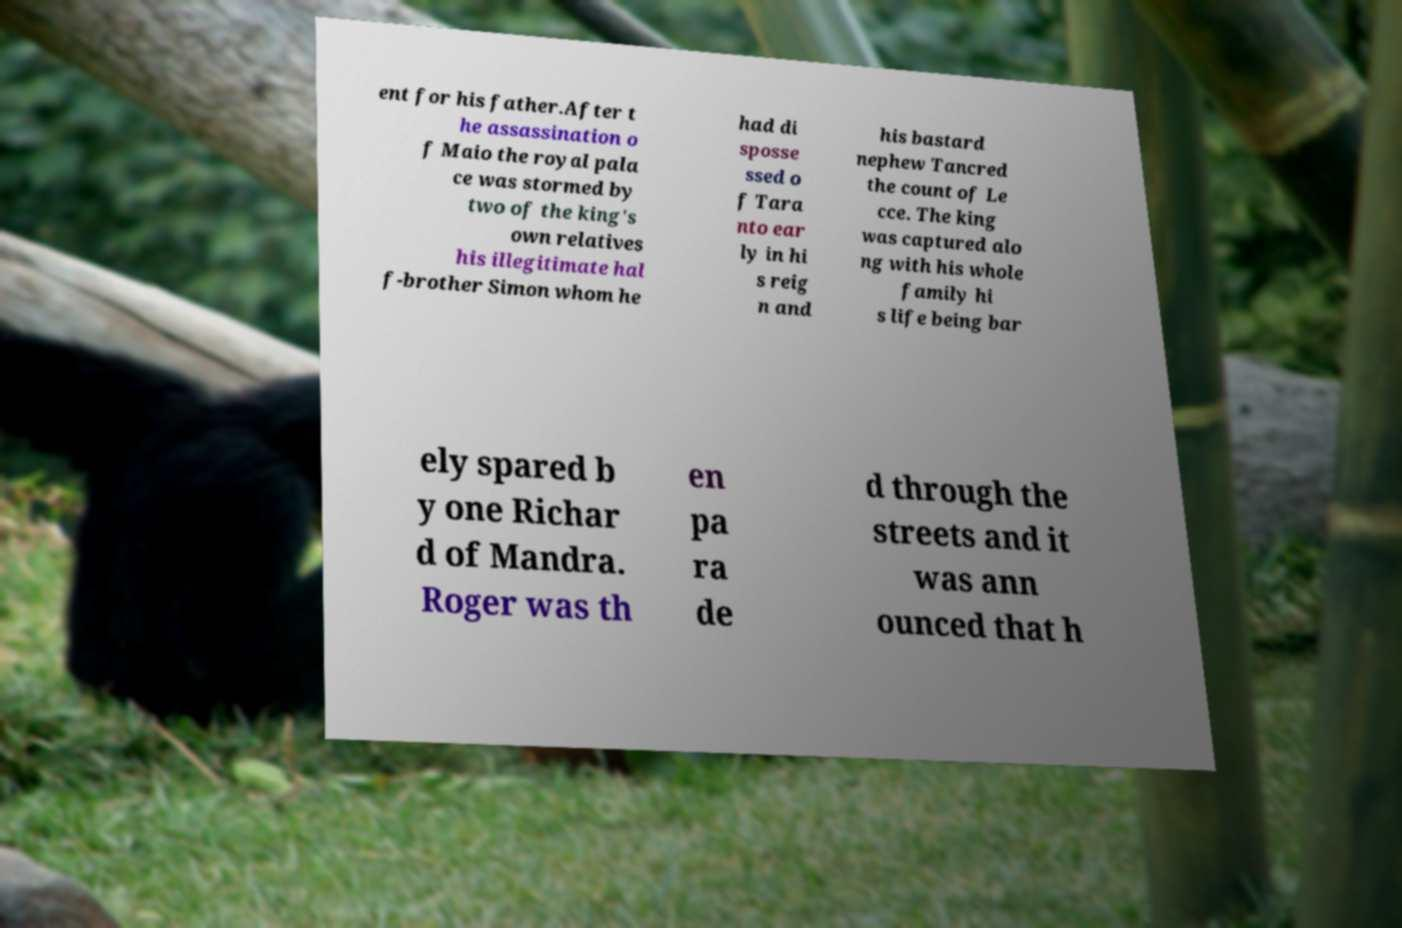Please read and relay the text visible in this image. What does it say? ent for his father.After t he assassination o f Maio the royal pala ce was stormed by two of the king's own relatives his illegitimate hal f-brother Simon whom he had di sposse ssed o f Tara nto ear ly in hi s reig n and his bastard nephew Tancred the count of Le cce. The king was captured alo ng with his whole family hi s life being bar ely spared b y one Richar d of Mandra. Roger was th en pa ra de d through the streets and it was ann ounced that h 